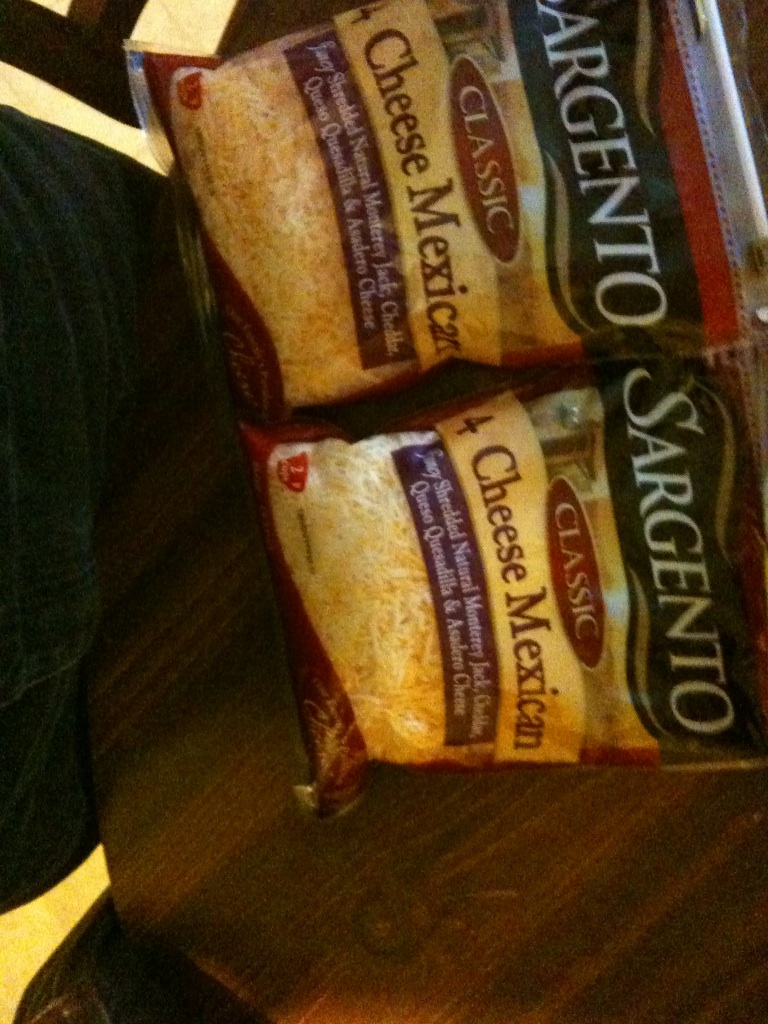How could this cheese blend be marketed for an exotic cooking show? Welcome to 'Culinary Adventures with Flavor Fusion!' Today, we are embarking on a journey through the heart of Mexican cuisine with the star of the show – the Sargento Classic 4 Cheese Mexican blend. Our chef will be creating dishes that dance with flavors and melt in your mouth.
First, we'll prepare cheesy stuffed poblano peppers, where the Asadero brings a creamy, melty texture. Next, we'll create a vibrant fiesta of flavors in our Mexican pizza, where Cheddar sharpens the taste, and Monterey Jack smooths it to perfection. Finally, we'll indulge in a decadent Queso Quesadilla fondue, making every dip a warm, comforting experience. Join us in celebrating the beauty and versatility of these four distinct cheeses coming together for an unforgettable culinary extravaganza! 